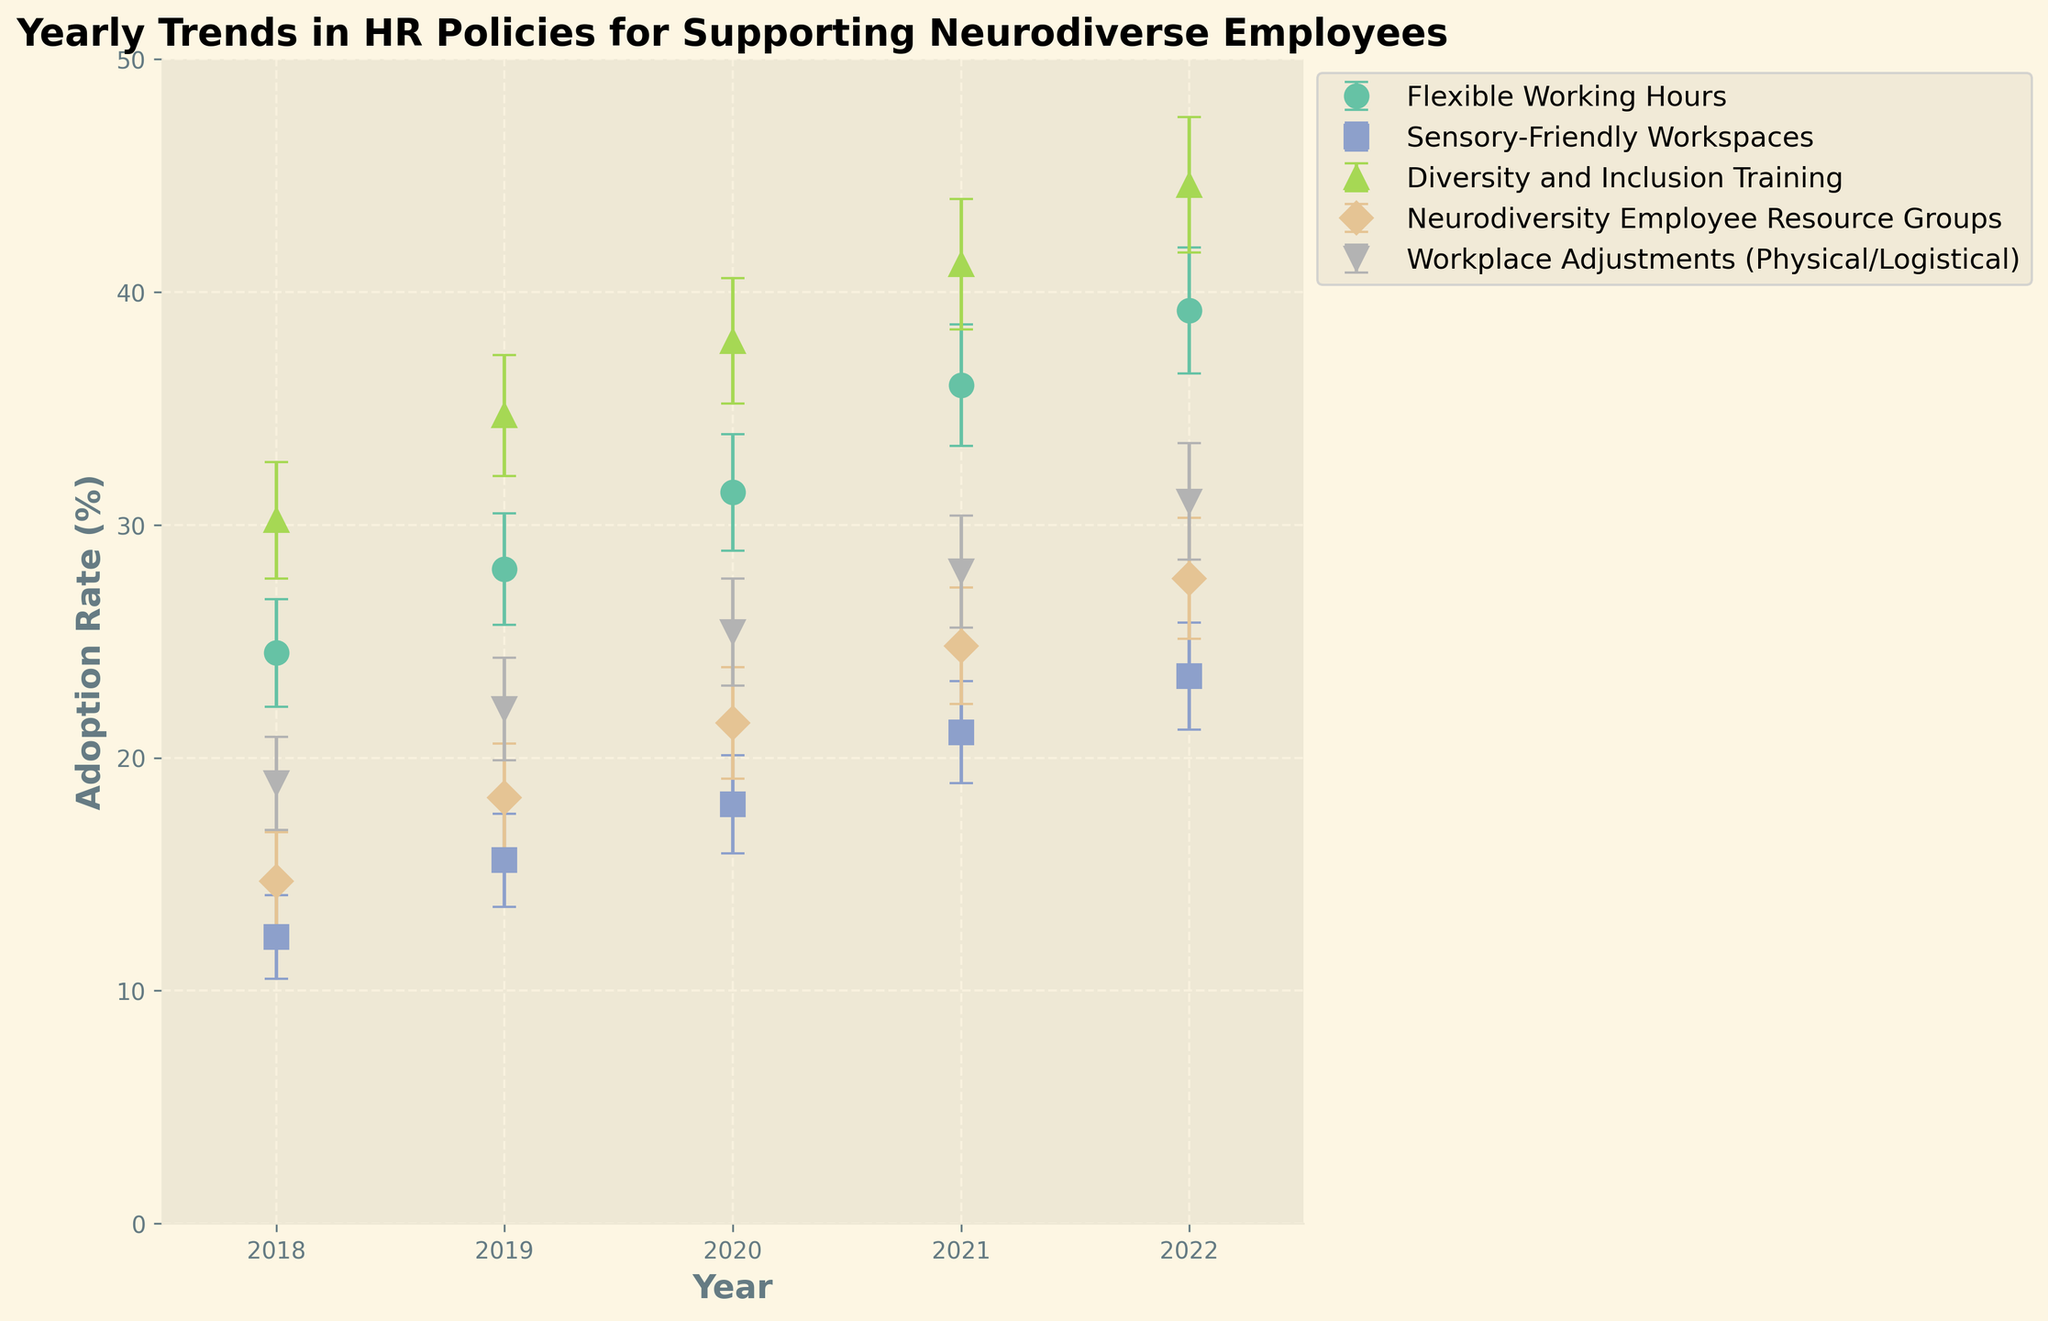How many policies are tracked in the plot? There are 5 distinct lines, each representing a different policy.
Answer: 5 What is the title of the plot? The title is clearly stated at the top of the plot.
Answer: Yearly Trends in HR Policies for Supporting Neurodiverse Employees Which policy had the highest adoption rate in 2020? The data point for 2020 with the highest value on the y-axis is 'Diversity and Inclusion Training'.
Answer: Diversity and Inclusion Training What is the error margin for Flexible Working Hours in 2021? The error margin value is directly given next to the data point for Flexible Working Hours in 2021.
Answer: 2.6 How does the adoption rate of Sensory-Friendly Workspaces in 2022 compare to 2018? Subtract the 2018 rate (12.3) from the 2022 rate (23.5). The 2022 rate is higher.
Answer: 11.2 What is the average adoption rate for Neurodiversity Employee Resource Groups from 2018 to 2022? Sum the adoption rates for the years 2018 to 2022 and divide by the number of years: (14.7 + 18.3 + 21.5 + 24.8 + 27.7) / 5.
Answer: 21.4 Between which two consecutive years did the Workplace Adjustments policy see the largest increase? Calculate the difference in adoption rates between each consecutive year and find the maximum: 2018-2019, 2019-2020, 2020-2021, and 2021-2022. Largest increase is between 2018-2019 and 2020-2021.
Answer: 2020 and 2021 Which policy had the lowest adoption rate in 2018? The y-axis value for 2018 that is the smallest corresponds to 'Sensory-Friendly Workspaces'.
Answer: Sensory-Friendly Workspaces What is the trend in adoption rate for Workplace Adjustments from 2018 to 2022? Observing the line for Workplace Adjustments, the adoption rate consistently increases each year.
Answer: Increasing Which policy had the smallest error margin in 2022? Compare the error margins for 2022, and identify the smallest one, which is for 'Sensory-Friendly Workspaces'.
Answer: Sensory-Friendly Workspaces 